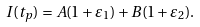<formula> <loc_0><loc_0><loc_500><loc_500>I ( t _ { p } ) = A ( 1 + \varepsilon _ { 1 } ) + B ( 1 + \varepsilon _ { 2 } ) .</formula> 